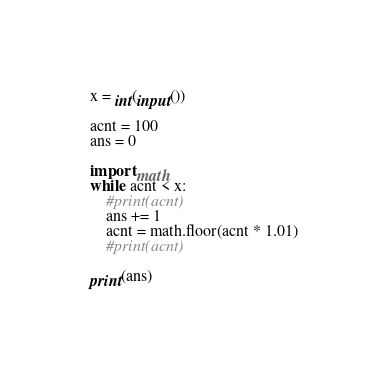Convert code to text. <code><loc_0><loc_0><loc_500><loc_500><_Python_>x = int(input())

acnt = 100
ans = 0

import math
while acnt < x:
    #print(acnt)
    ans += 1
    acnt = math.floor(acnt * 1.01)
    #print(acnt)

print(ans)</code> 